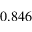Convert formula to latex. <formula><loc_0><loc_0><loc_500><loc_500>0 . 8 4 6</formula> 